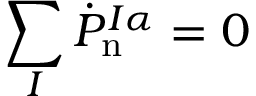Convert formula to latex. <formula><loc_0><loc_0><loc_500><loc_500>\sum _ { I } \dot { P } _ { n } ^ { I \alpha } = 0</formula> 